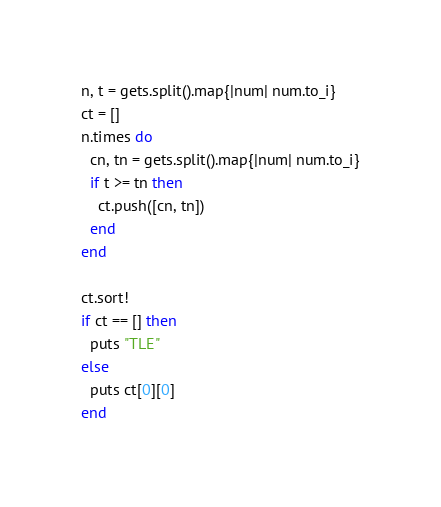<code> <loc_0><loc_0><loc_500><loc_500><_Ruby_>n, t = gets.split().map{|num| num.to_i}
ct = []
n.times do
  cn, tn = gets.split().map{|num| num.to_i}
  if t >= tn then
    ct.push([cn, tn])
  end
end

ct.sort!
if ct == [] then
  puts "TLE"
else
  puts ct[0][0]
end
</code> 